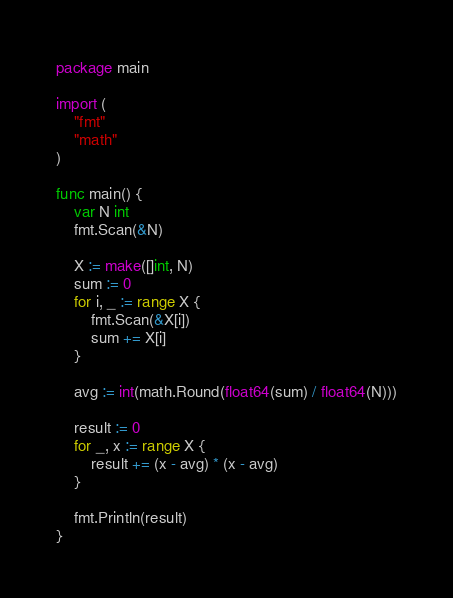<code> <loc_0><loc_0><loc_500><loc_500><_Go_>package main

import (
	"fmt"
	"math"
)

func main() {
	var N int
	fmt.Scan(&N)

	X := make([]int, N)
	sum := 0
	for i, _ := range X {
		fmt.Scan(&X[i])
		sum += X[i]
	}

	avg := int(math.Round(float64(sum) / float64(N)))

	result := 0
	for _, x := range X {
		result += (x - avg) * (x - avg)
	}

	fmt.Println(result)
}
</code> 